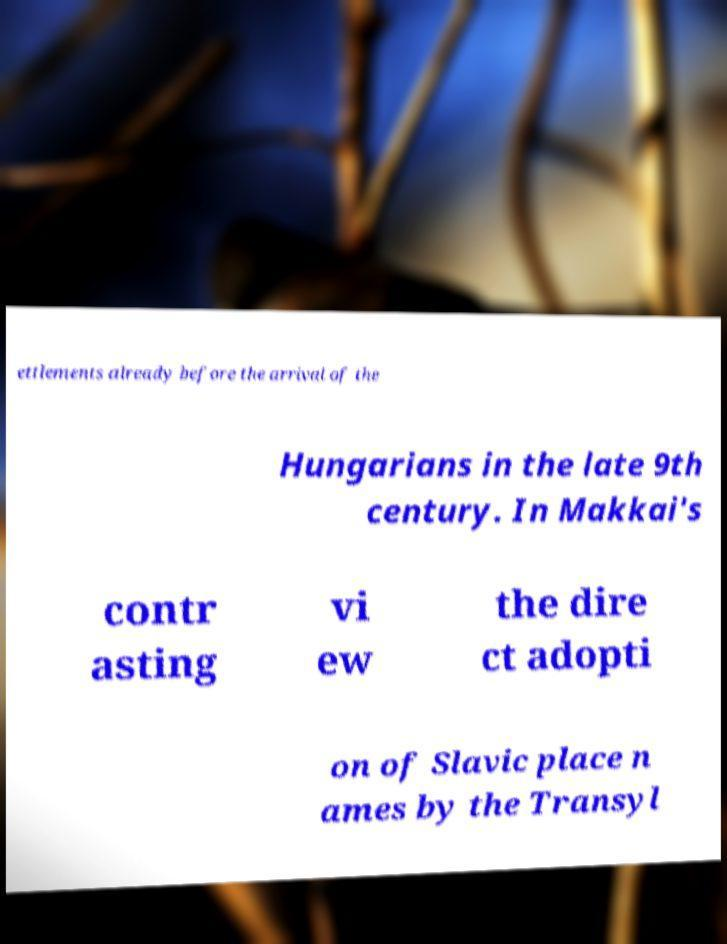What messages or text are displayed in this image? I need them in a readable, typed format. ettlements already before the arrival of the Hungarians in the late 9th century. In Makkai's contr asting vi ew the dire ct adopti on of Slavic place n ames by the Transyl 